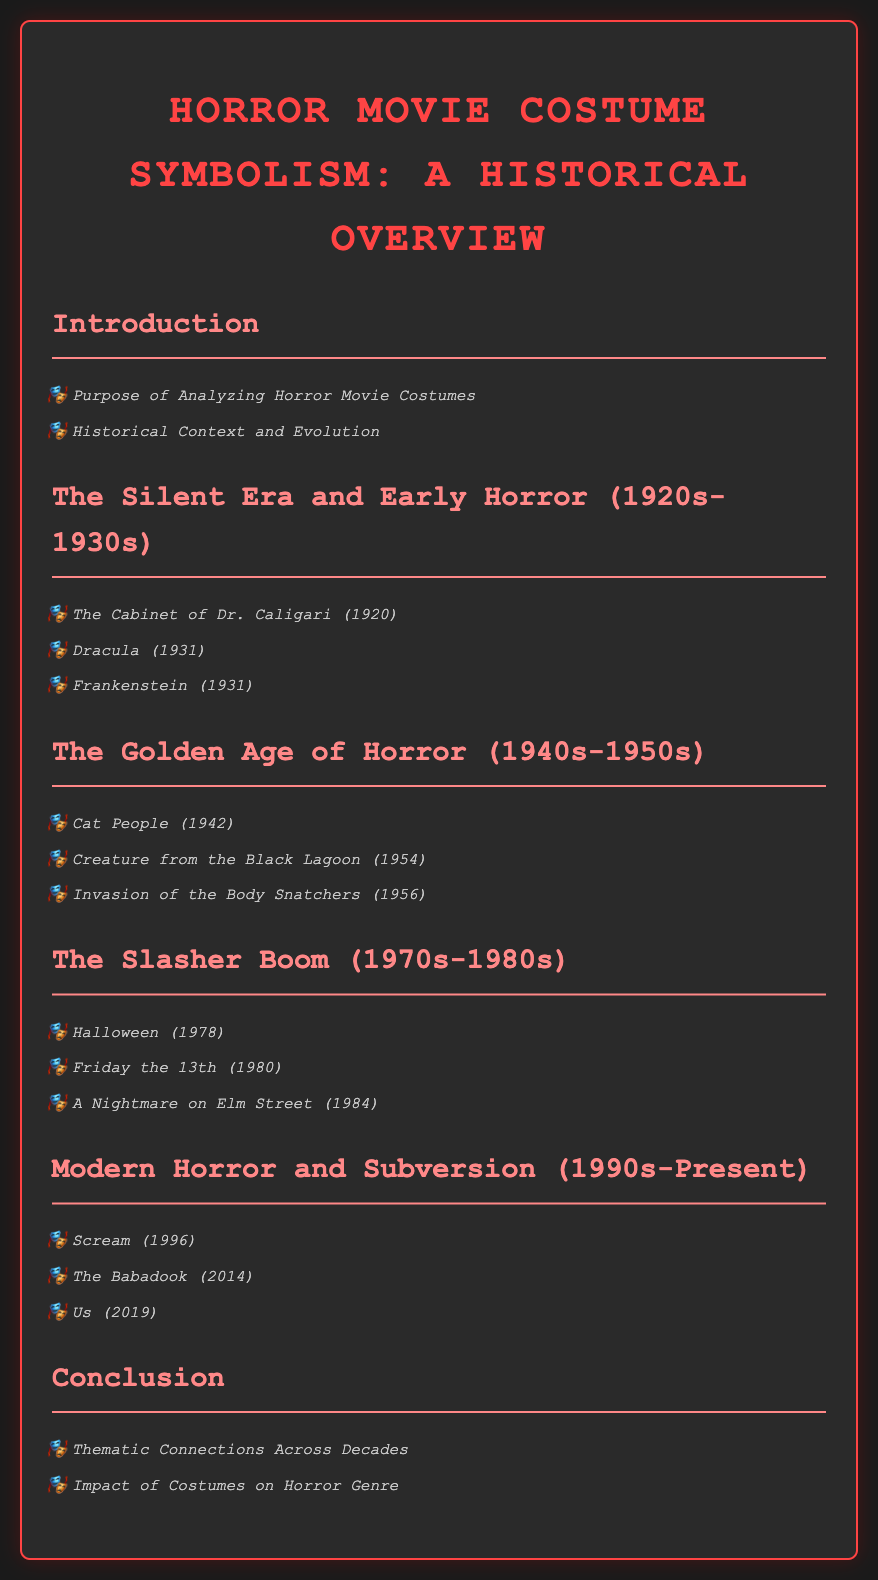What is the title of the document? The title is presented prominently at the top of the document and is "Horror Movie Costume Symbolism: A Historical Overview."
Answer: Horror Movie Costume Symbolism: A Historical Overview Which film is associated with the Silent Era? The section specifically highlighting the Silent Era lists "The Cabinet of Dr. Caligari (1920)" as one notable film.
Answer: The Cabinet of Dr. Caligari (1920) What year was "Halloween" released? In the section discussing the Slasher Boom, "Halloween" is listed with its release year of 1978.
Answer: 1978 What thematic connection is discussed in the conclusion? The conclusion section mentions "Thematic Connections Across Decades" as a key focus.
Answer: Thematic Connections Across Decades Which film from the Modern Horror section was released in 2014? The document lists "The Babadook (2014)" as a significant entry in the Modern Horror section.
Answer: The Babadook (2014) What is analyzed in the introduction? The introduction discusses "Purpose of Analyzing Horror Movie Costumes," indicating its thematic focus.
Answer: Purpose of Analyzing Horror Movie Costumes How many films are listed in the Golden Age of Horror? There are three films listed in this section: "Cat People," "Creature from the Black Lagoon," and "Invasion of the Body Snatchers."
Answer: Three Who directed "Dracula"? The document does not specify the director but mentions "Dracula (1931)" as one of the films from the Silent Era.
Answer: Dracula (1931) What type of movie is "Scream"? In the Modern Horror section, "Scream" is categorized under contemporary horror films.
Answer: Contemporary horror 